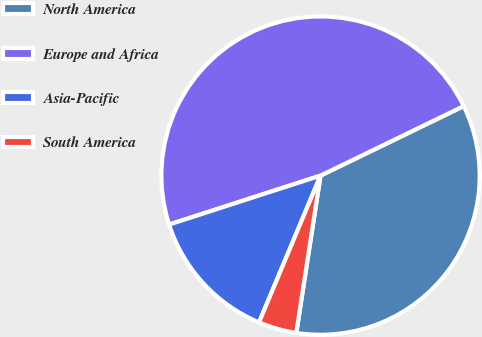Convert chart to OTSL. <chart><loc_0><loc_0><loc_500><loc_500><pie_chart><fcel>North America<fcel>Europe and Africa<fcel>Asia-Pacific<fcel>South America<nl><fcel>34.63%<fcel>47.79%<fcel>13.71%<fcel>3.88%<nl></chart> 